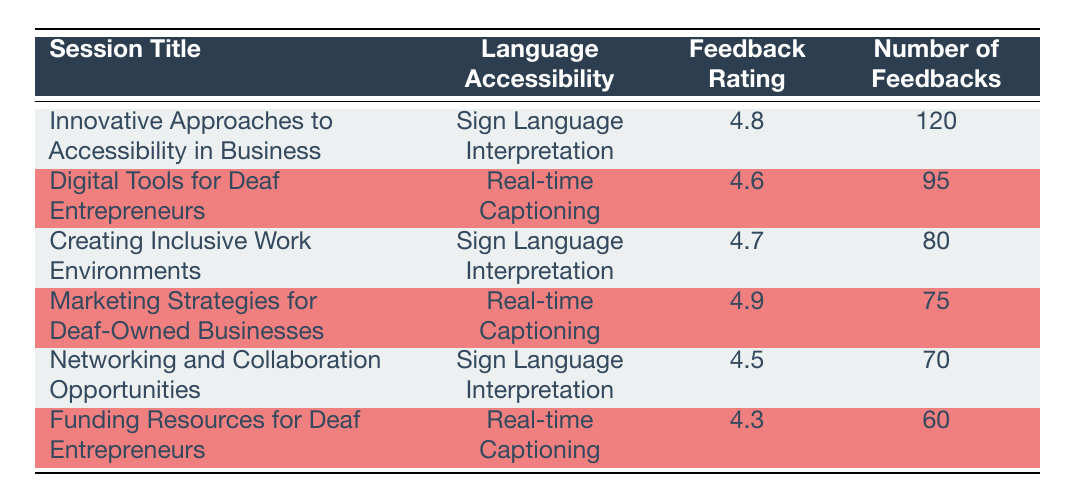What is the feedback rating for the session "Digital Tools for Deaf Entrepreneurs"? The table shows that the feedback rating for the session titled "Digital Tools for Deaf Entrepreneurs" is listed under the "Feedback Rating" column, which shows a value of 4.6.
Answer: 4.6 Which session had the highest number of feedbacks? By looking at the "Number of Feedbacks" column, we see that the session "Innovative Approaches to Accessibility in Business" has the highest value at 120.
Answer: Innovative Approaches to Accessibility in Business What is the average feedback rating for sessions with Sign Language Interpretation? The sessions with Sign Language Interpretation and their ratings are: 4.8 (Innovative Approaches to Accessibility in Business), 4.7 (Creating Inclusive Work Environments), and 4.5 (Networking and Collaboration Opportunities). The sum is 4.8 + 4.7 + 4.5 = 14.0, and there are 3 sessions, so the average is 14.0 / 3 = 4.67.
Answer: 4.67 Is there a session titled "Funding Resources for Deaf Entrepreneurs"? The session title "Funding Resources for Deaf Entrepreneurs" is found in the table, confirming that this session does exist as part of the feedback ratings.
Answer: Yes Which language accessibility option has a higher average feedback rating: Sign Language Interpretation or Real-time Captioning? First, calculate the average for each category. For Sign Language Interpretation, the ratings are 4.8, 4.7, and 4.5, summing to 14.0, so the average is 14.0 / 3 = 4.67. For Real-time Captioning, the ratings are 4.6, 4.9, and 4.3, summing to 13.8, so the average is 13.8 / 3 = 4.6. Comparing the averages, 4.67 (Sign Language Interpretation) is higher than 4.6 (Real-time Captioning).
Answer: Sign Language Interpretation How many feedbacks were received for the session with the feedback rating of 4.3? The session associated with the rating of 4.3 is "Funding Resources for Deaf Entrepreneurs." Referring to the "Number of Feedbacks" column, we see that it received 60 feedbacks.
Answer: 60 